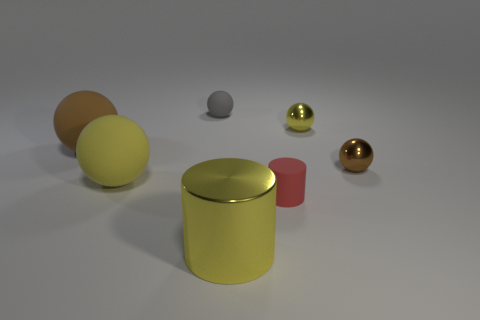The red rubber object is what size?
Offer a terse response. Small. Does the small matte ball have the same color as the tiny cylinder?
Your response must be concise. No. How many things are large yellow balls or tiny rubber things in front of the gray thing?
Ensure brevity in your answer.  2. What number of yellow things are behind the brown ball that is left of the small thing that is on the left side of the large yellow metal thing?
Make the answer very short. 1. There is a big sphere that is the same color as the shiny cylinder; what is it made of?
Your response must be concise. Rubber. How many big spheres are there?
Give a very brief answer. 2. Does the brown sphere that is on the left side of the gray rubber sphere have the same size as the large yellow shiny thing?
Your answer should be very brief. Yes. What number of matte objects are either big brown things or gray cylinders?
Your answer should be compact. 1. What number of small brown things are in front of the yellow sphere that is in front of the small brown object?
Ensure brevity in your answer.  0. There is a yellow thing that is both left of the small yellow shiny thing and to the right of the yellow rubber thing; what is its shape?
Give a very brief answer. Cylinder. 